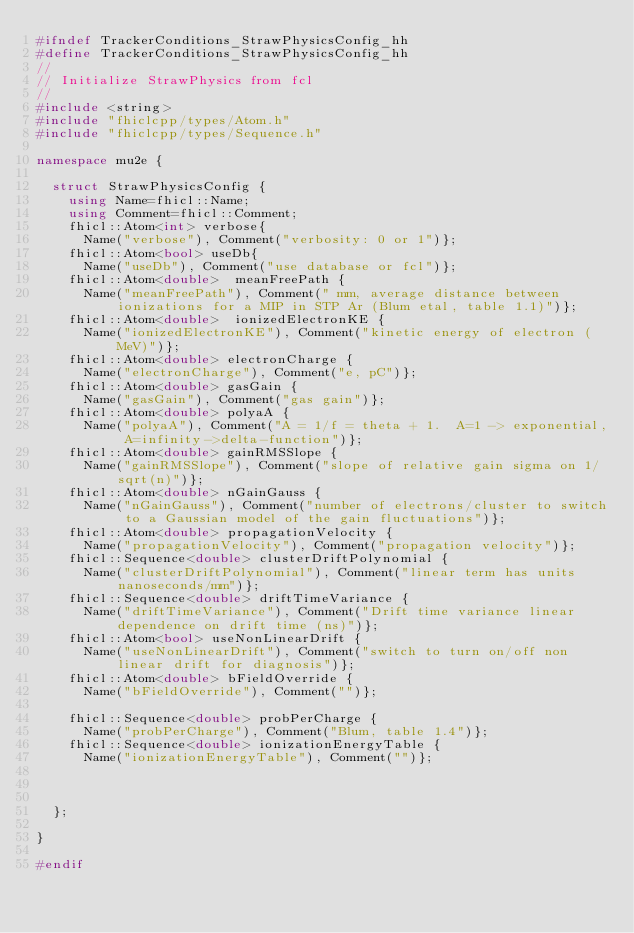<code> <loc_0><loc_0><loc_500><loc_500><_C++_>#ifndef TrackerConditions_StrawPhysicsConfig_hh
#define TrackerConditions_StrawPhysicsConfig_hh
//
// Initialize StrawPhysics from fcl
//
#include <string>
#include "fhiclcpp/types/Atom.h"
#include "fhiclcpp/types/Sequence.h"

namespace mu2e {

  struct StrawPhysicsConfig {
    using Name=fhicl::Name;
    using Comment=fhicl::Comment;
    fhicl::Atom<int> verbose{
      Name("verbose"), Comment("verbosity: 0 or 1")}; 
    fhicl::Atom<bool> useDb{
      Name("useDb"), Comment("use database or fcl")}; 
    fhicl::Atom<double>  meanFreePath {
      Name("meanFreePath"), Comment(" mm, average distance between ionizations for a MIP in STP Ar (Blum etal, table 1.1)")};
    fhicl::Atom<double>  ionizedElectronKE {
      Name("ionizedElectronKE"), Comment("kinetic energy of electron (MeV)")};
    fhicl::Atom<double> electronCharge {
      Name("electronCharge"), Comment("e, pC")};
    fhicl::Atom<double> gasGain {
      Name("gasGain"), Comment("gas gain")};
    fhicl::Atom<double> polyaA {
      Name("polyaA"), Comment("A = 1/f = theta + 1.  A=1 -> exponential, A=infinity->delta-function")};
    fhicl::Atom<double> gainRMSSlope {
      Name("gainRMSSlope"), Comment("slope of relative gain sigma on 1/sqrt(n)")};
    fhicl::Atom<double> nGainGauss {
      Name("nGainGauss"), Comment("number of electrons/cluster to switch to a Gaussian model of the gain fluctuations")};
    fhicl::Atom<double> propagationVelocity {
      Name("propagationVelocity"), Comment("propagation velocity")};
    fhicl::Sequence<double> clusterDriftPolynomial {
      Name("clusterDriftPolynomial"), Comment("linear term has units nanoseconds/mm")};
    fhicl::Sequence<double> driftTimeVariance {
      Name("driftTimeVariance"), Comment("Drift time variance linear dependence on drift time (ns)")};
    fhicl::Atom<bool> useNonLinearDrift {
      Name("useNonLinearDrift"), Comment("switch to turn on/off non linear drift for diagnosis")};
    fhicl::Atom<double> bFieldOverride {
      Name("bFieldOverride"), Comment("")};

    fhicl::Sequence<double> probPerCharge {
      Name("probPerCharge"), Comment("Blum, table 1.4")};
    fhicl::Sequence<double> ionizationEnergyTable {
      Name("ionizationEnergyTable"), Comment("")};



  };

}

#endif
</code> 